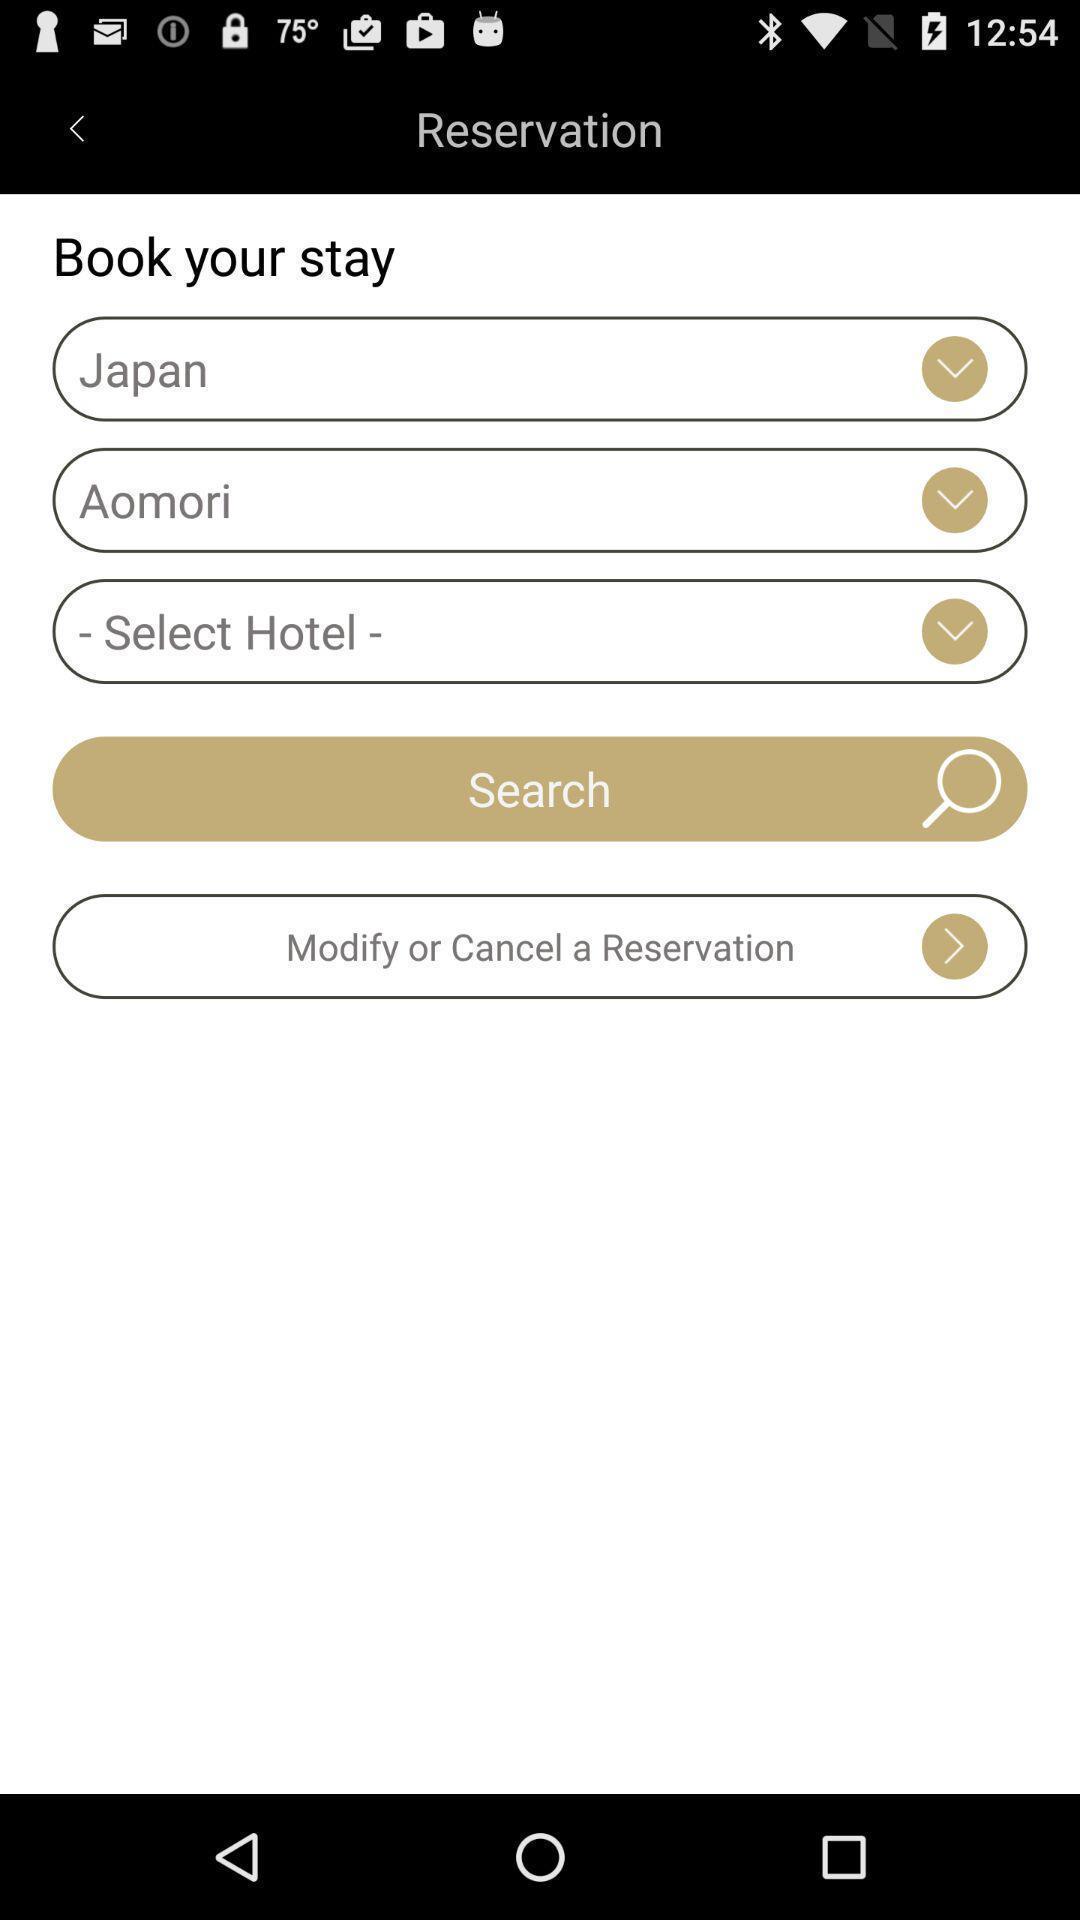What can you discern from this picture? Search option to find hotels in different locations for booking. 